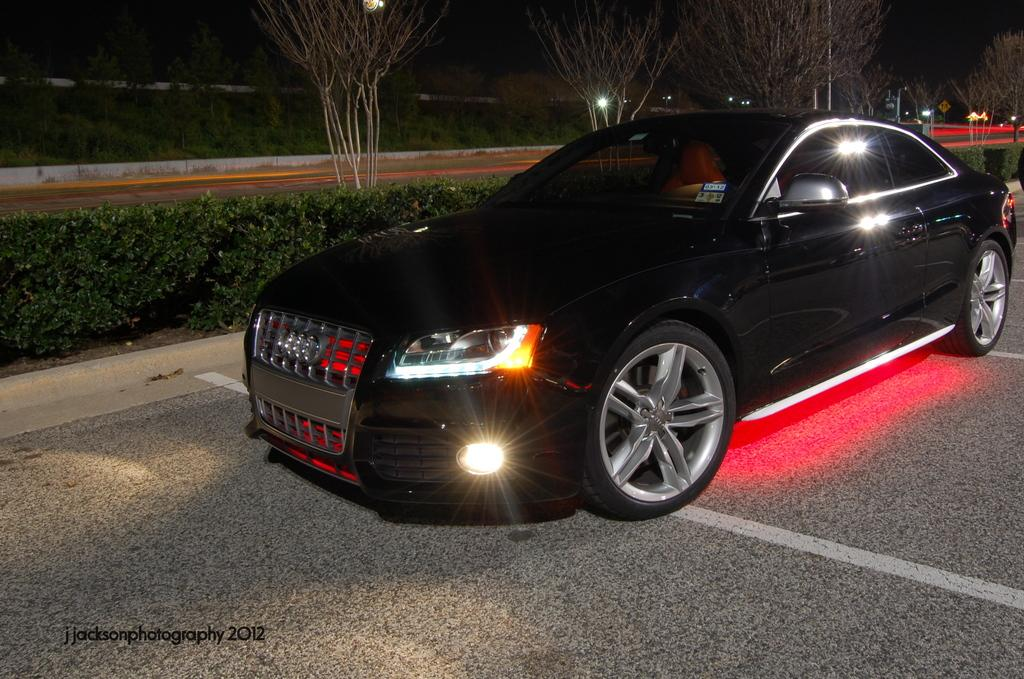What is the main subject of the image? There is a car in the image. Where is the car located in relation to the road? The car is beside the road. What can be seen behind the car in the image? There are many trees and plants behind the car. What time of day is depicted in the image? The image is captured at night. What feature of the car is turned on in the image? The headlights of the car are on. What type of tank is visible in the image? There is no tank present in the image; it features a car beside the road. What kind of apparatus is being used by the driver in the image? The image does not show the driver or any apparatus being used. 